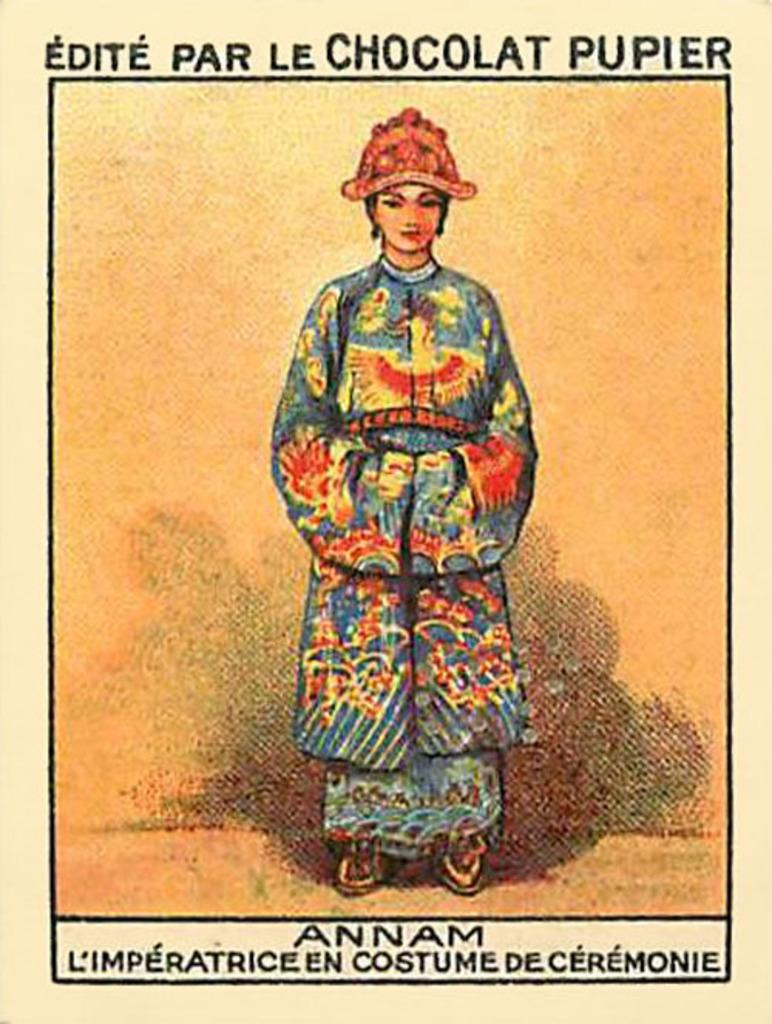What is present on the poster in the image? There is a poster in the image, which contains an image of a person. What else can be seen on the poster besides the image? There is text on the poster. How many clocks are visible on the poster in the image? There are no clocks visible on the poster in the image. What type of sign is depicted on the poster in the image? There is no sign depicted on the poster in the image; it contains an image of a person and text. 